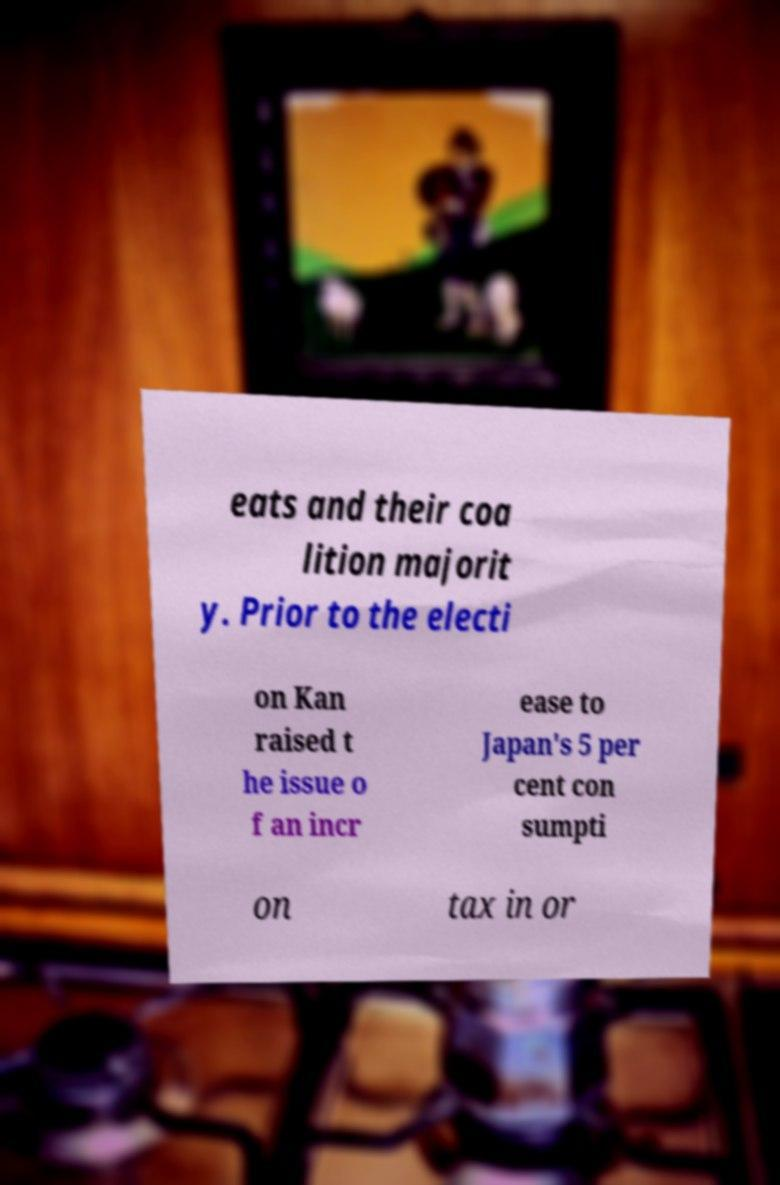Could you extract and type out the text from this image? eats and their coa lition majorit y. Prior to the electi on Kan raised t he issue o f an incr ease to Japan's 5 per cent con sumpti on tax in or 